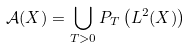<formula> <loc_0><loc_0><loc_500><loc_500>\mathcal { A } ( X ) = \bigcup _ { T > 0 } P _ { T } \left ( L ^ { 2 } ( X ) \right )</formula> 